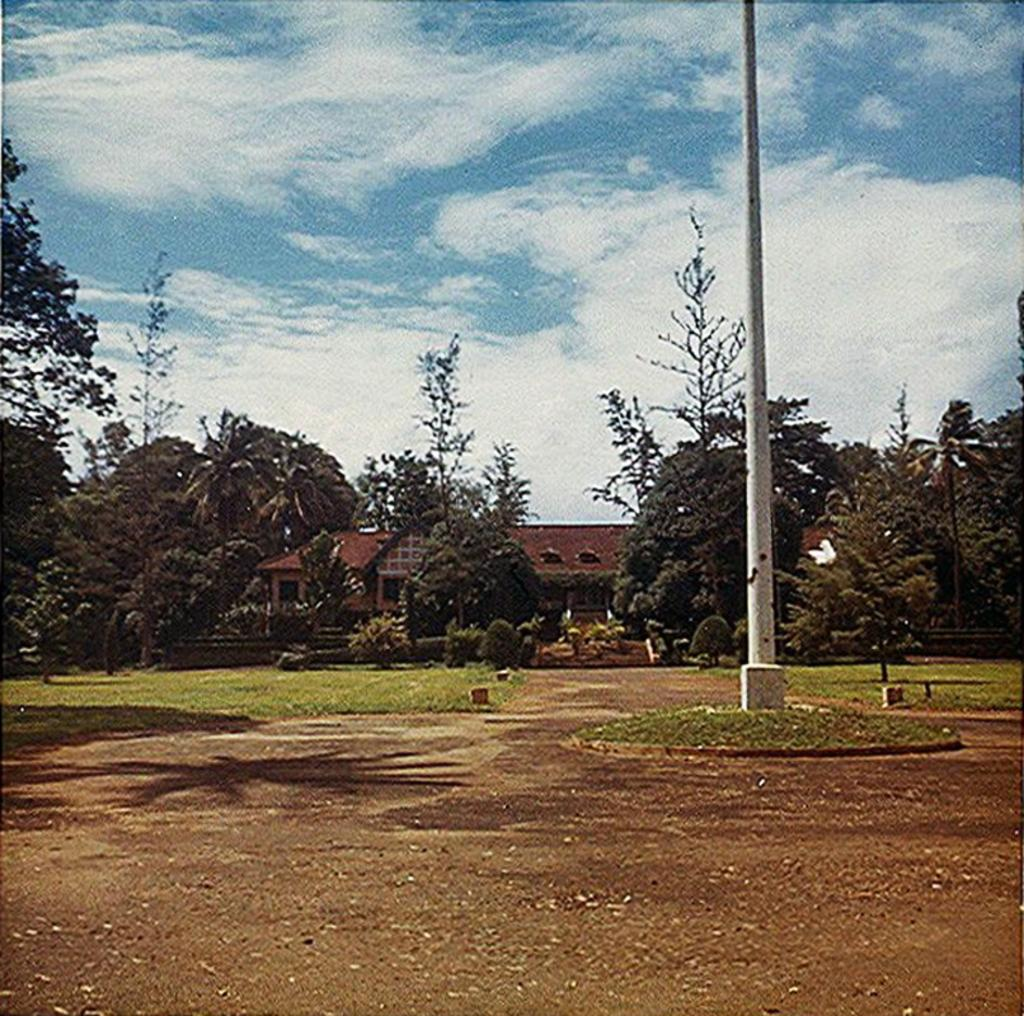What is located in the center of the image? There are trees, houses, a pole, and a light in the center of the image. What type of terrain is visible at the bottom of the image? There is sand and grass at the bottom of the image. What is visible at the top of the image? The sky is visible at the top of the image. How many horses are present in the image? There are no horses present in the image. What type of pot is used to join the sand and grass at the bottom of the image? There is no pot used to join the sand and grass in the image, as they are separate elements in the terrain. 